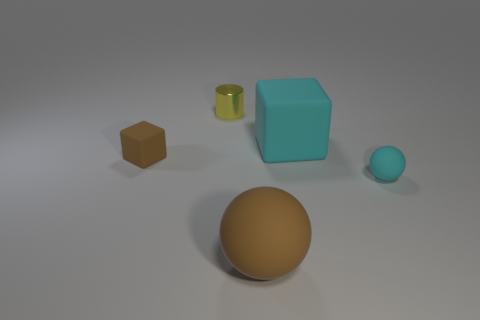Subtract all brown blocks. How many cyan spheres are left? 1 Subtract all tiny things. Subtract all red metal blocks. How many objects are left? 2 Add 5 cyan things. How many cyan things are left? 7 Add 5 small yellow objects. How many small yellow objects exist? 6 Add 3 big brown balls. How many objects exist? 8 Subtract 1 brown cubes. How many objects are left? 4 Subtract all blocks. How many objects are left? 3 Subtract 2 balls. How many balls are left? 0 Subtract all green cylinders. Subtract all brown balls. How many cylinders are left? 1 